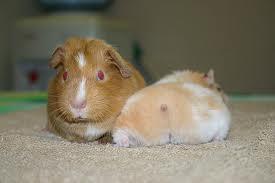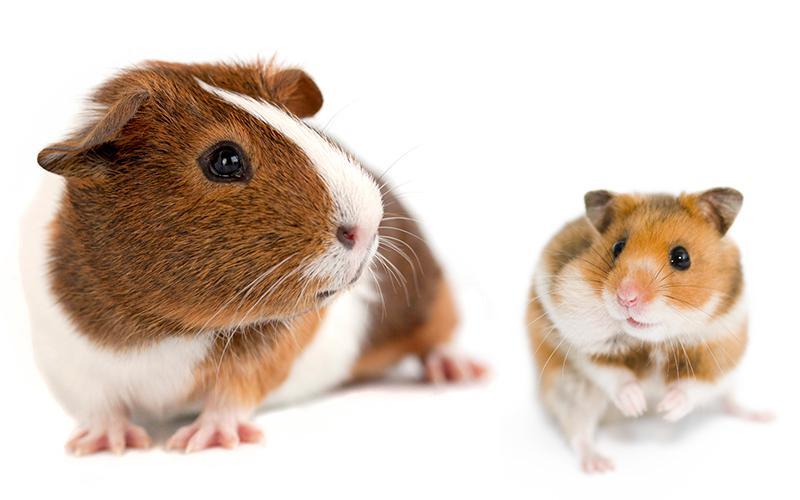The first image is the image on the left, the second image is the image on the right. Considering the images on both sides, is "The right image contains two rabbits." valid? Answer yes or no. No. The first image is the image on the left, the second image is the image on the right. Assess this claim about the two images: "One of the images features a small animal in between two rabbits, while the other image features at least two guinea pigs.". Correct or not? Answer yes or no. No. 